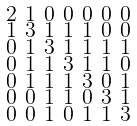<formula> <loc_0><loc_0><loc_500><loc_500>\begin{smallmatrix} 2 & 1 & 0 & 0 & 0 & 0 & 0 \\ 1 & 3 & 1 & 1 & 1 & 0 & 0 \\ 0 & 1 & 3 & 1 & 1 & 1 & 1 \\ 0 & 1 & 1 & 3 & 1 & 1 & 0 \\ 0 & 1 & 1 & 1 & 3 & 0 & 1 \\ 0 & 0 & 1 & 1 & 0 & 3 & 1 \\ 0 & 0 & 1 & 0 & 1 & 1 & 3 \end{smallmatrix}</formula> 